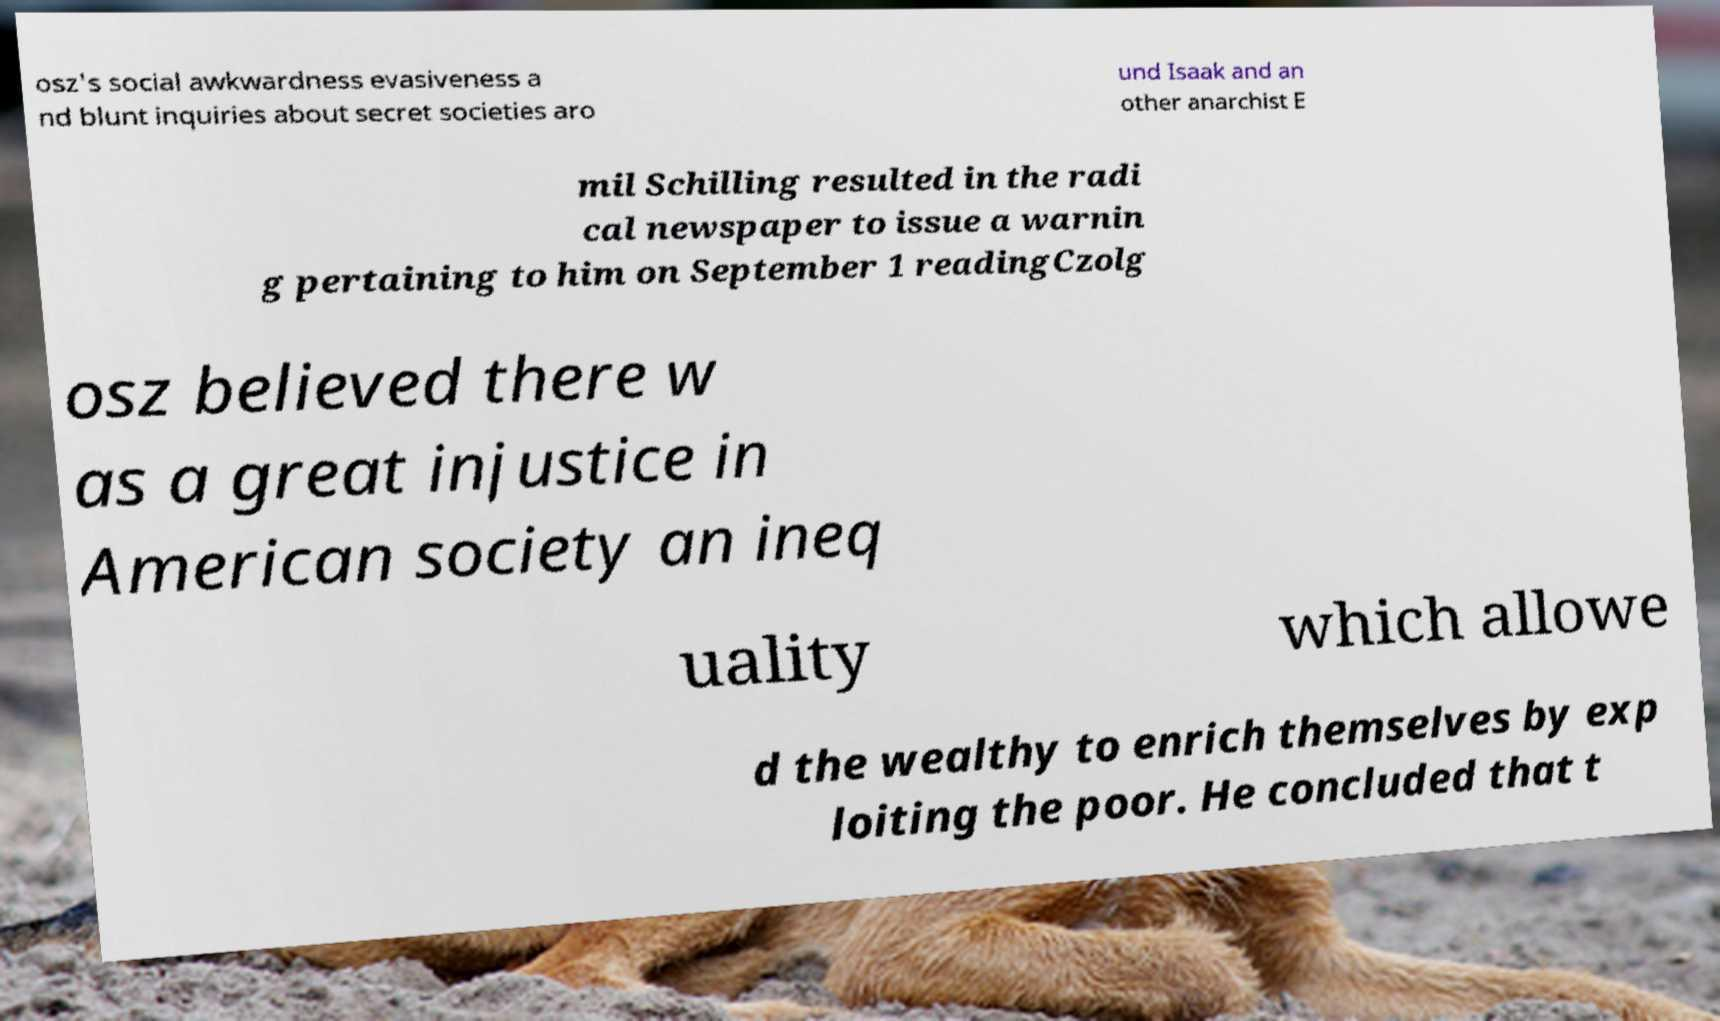There's text embedded in this image that I need extracted. Can you transcribe it verbatim? osz's social awkwardness evasiveness a nd blunt inquiries about secret societies aro und Isaak and an other anarchist E mil Schilling resulted in the radi cal newspaper to issue a warnin g pertaining to him on September 1 readingCzolg osz believed there w as a great injustice in American society an ineq uality which allowe d the wealthy to enrich themselves by exp loiting the poor. He concluded that t 